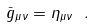Convert formula to latex. <formula><loc_0><loc_0><loc_500><loc_500>\bar { g } _ { \mu \nu } = \eta _ { \mu \nu } \ .</formula> 